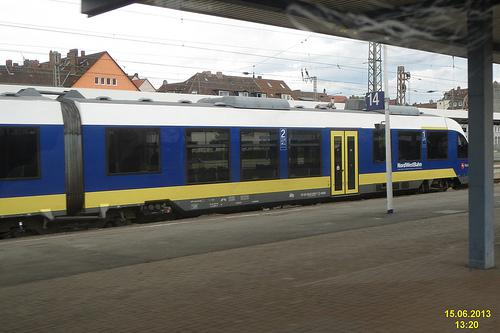Question: where could this photo have been taken?
Choices:
A. Mall.
B. Airport.
C. House.
D. Train station.
Answer with the letter. Answer: D Question: how do trains usually operate in modern times?
Choices:
A. Electricity.
B. Engine.
C. Magnets.
D. Magic.
Answer with the letter. Answer: B Question: what color takes up most of the area seen on side of train?
Choices:
A. Blue.
B. Black.
C. Yellow.
D. Green.
Answer with the letter. Answer: A 